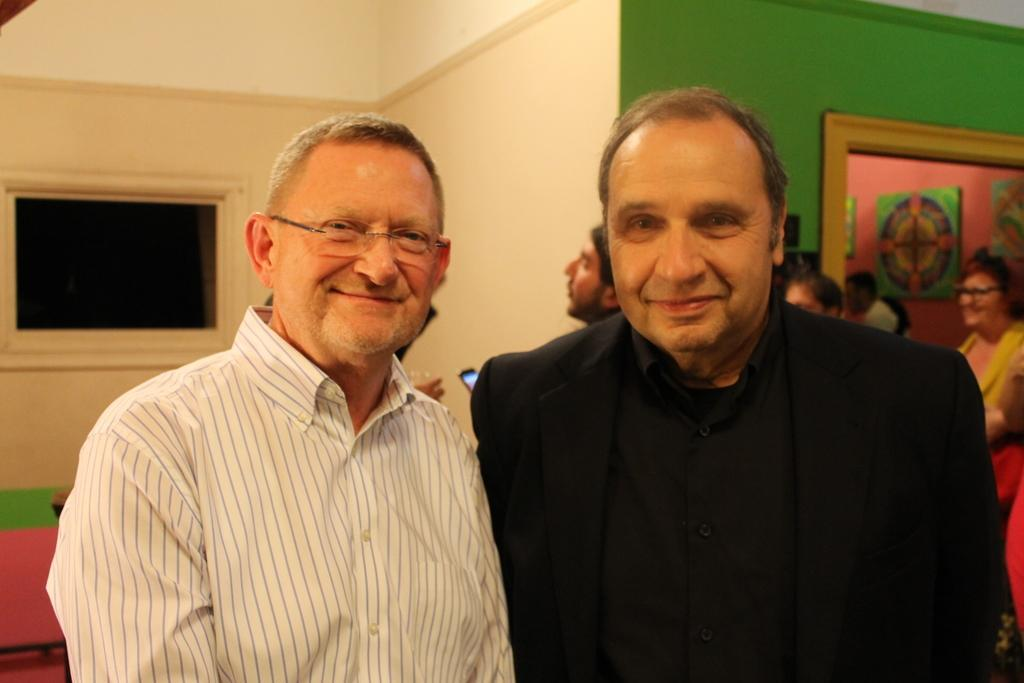Who can be seen in the front of the image? There are persons in the front of the image. What expression do the persons in the front have? The persons in the front are smiling. What can be seen in the background of the image? There are persons, a mirror, and a wall in the background of the image. What historical event is being discussed by the persons in the image? There is no indication of a historical event being discussed in the image. Can you tell me how many frogs are present in the image? There are no frogs present in the image. 